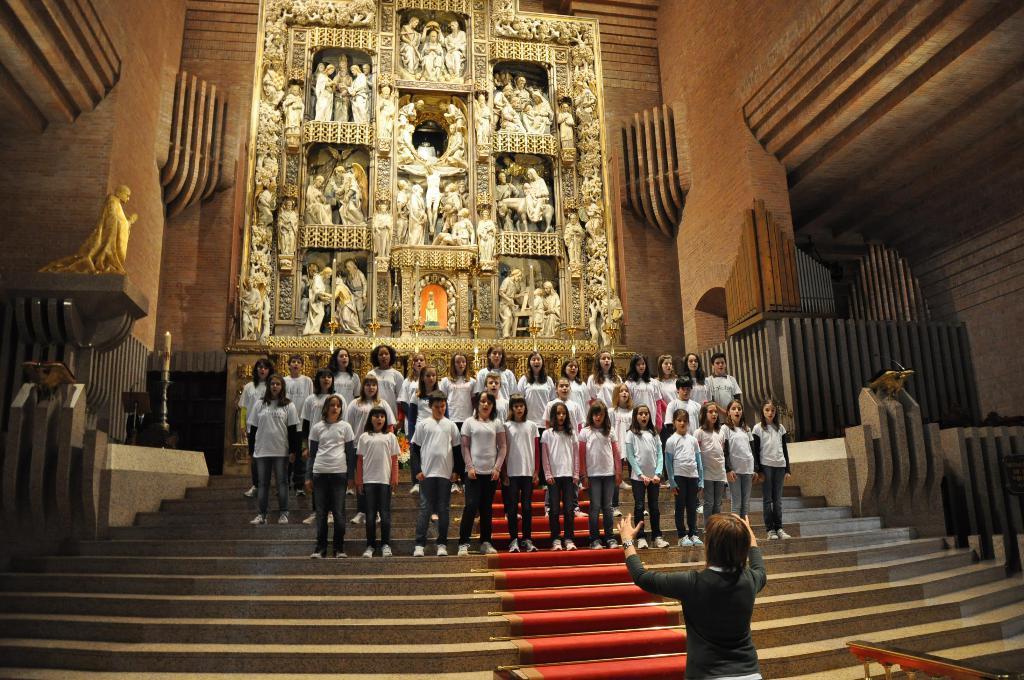Can you describe this image briefly? In this picture I can see a woman in front who is standing and in the middle of this picture I see the stairs on which there are number of people. In the background I see the walls and number of sculptures. 